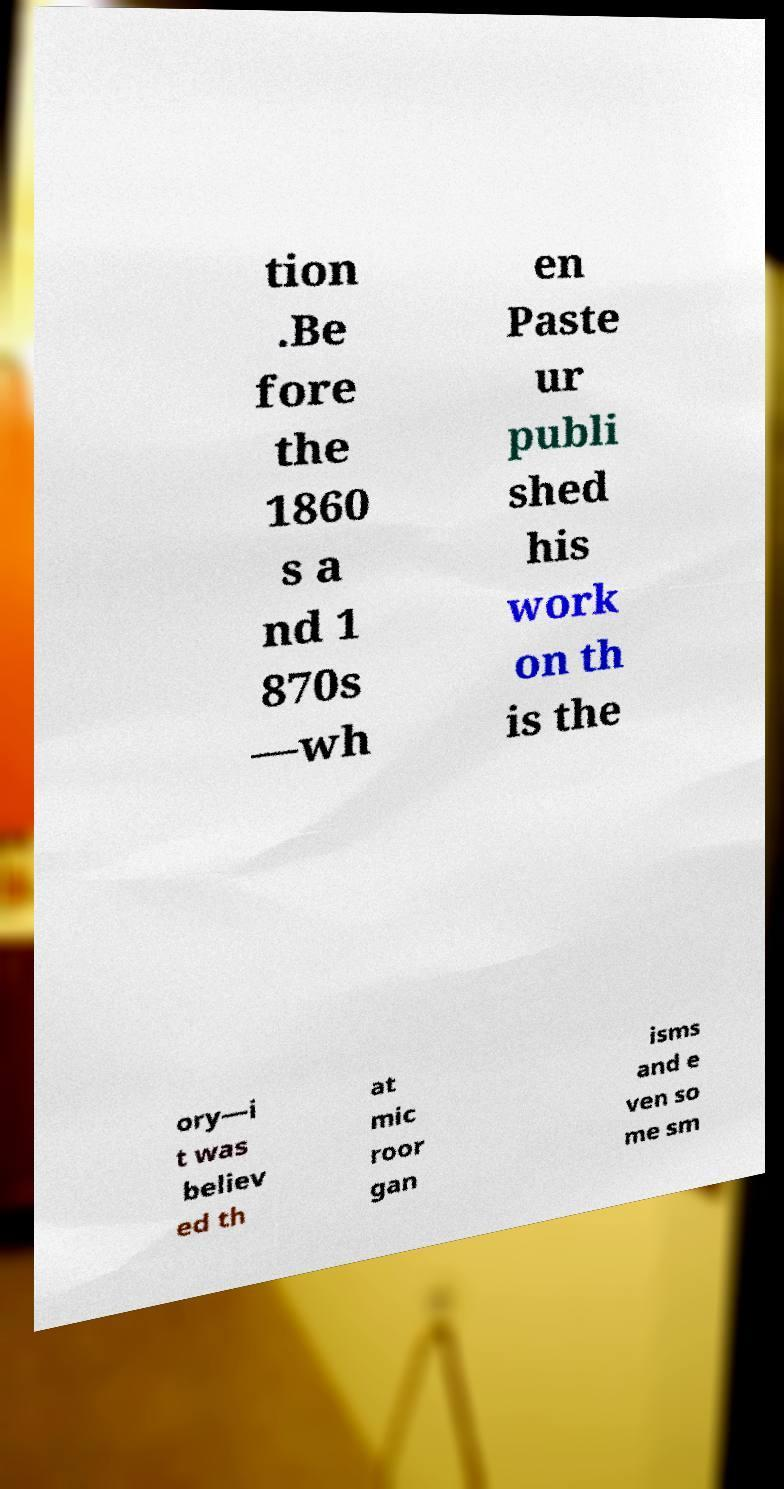There's text embedded in this image that I need extracted. Can you transcribe it verbatim? tion .Be fore the 1860 s a nd 1 870s —wh en Paste ur publi shed his work on th is the ory—i t was believ ed th at mic roor gan isms and e ven so me sm 